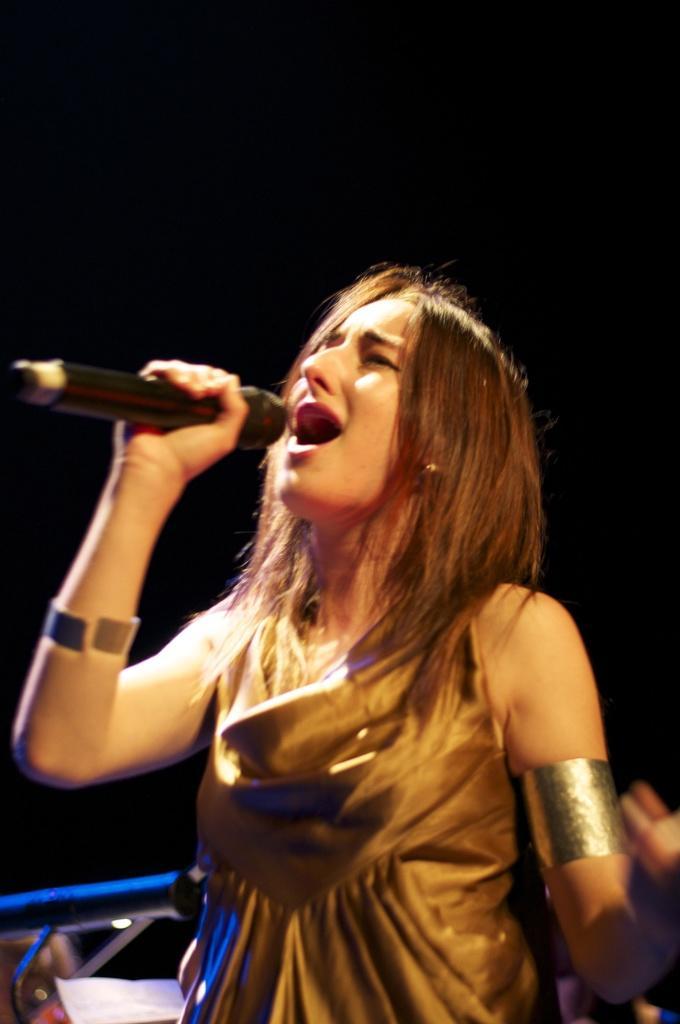Could you give a brief overview of what you see in this image? This image has a woman singing and holding a mike is wearing a golden colour dress. 